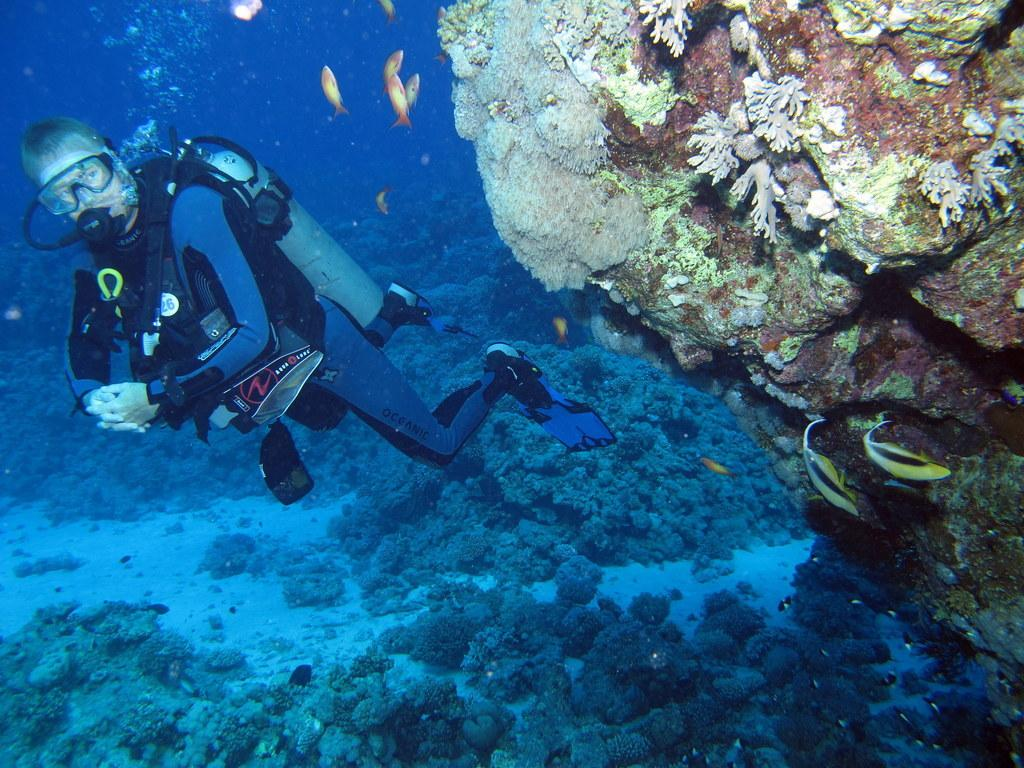What is the main subject of the image? The image depicts a water body. What activity is the person in the image engaged in? There is a person performing scuba diving in the water. What other living creatures can be seen in the water? There are fishes in the water. What type of underwater terrain is visible in the image? Rocks are visible in the water. What type of books can be seen floating in the water? There are no books visible in the image; it depicts a person scuba diving in a water body with fishes and rocks. 